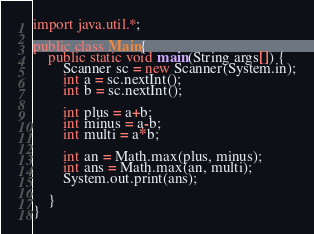<code> <loc_0><loc_0><loc_500><loc_500><_Java_>import java.util.*;

public class Main{
    public static void main(String args[]) {
        Scanner sc = new Scanner(System.in);
        int a = sc.nextInt();
        int b = sc.nextInt();

        int plus = a+b;
        int minus = a-b;
        int multi = a*b;

        int an = Math.max(plus, minus);
        int ans = Math.max(an, multi);
        System.out.print(ans);

    }
}</code> 